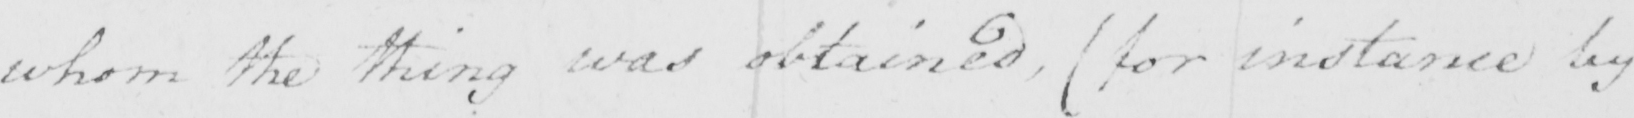What text is written in this handwritten line? whom the thing was obtained ,  ( for instance by 